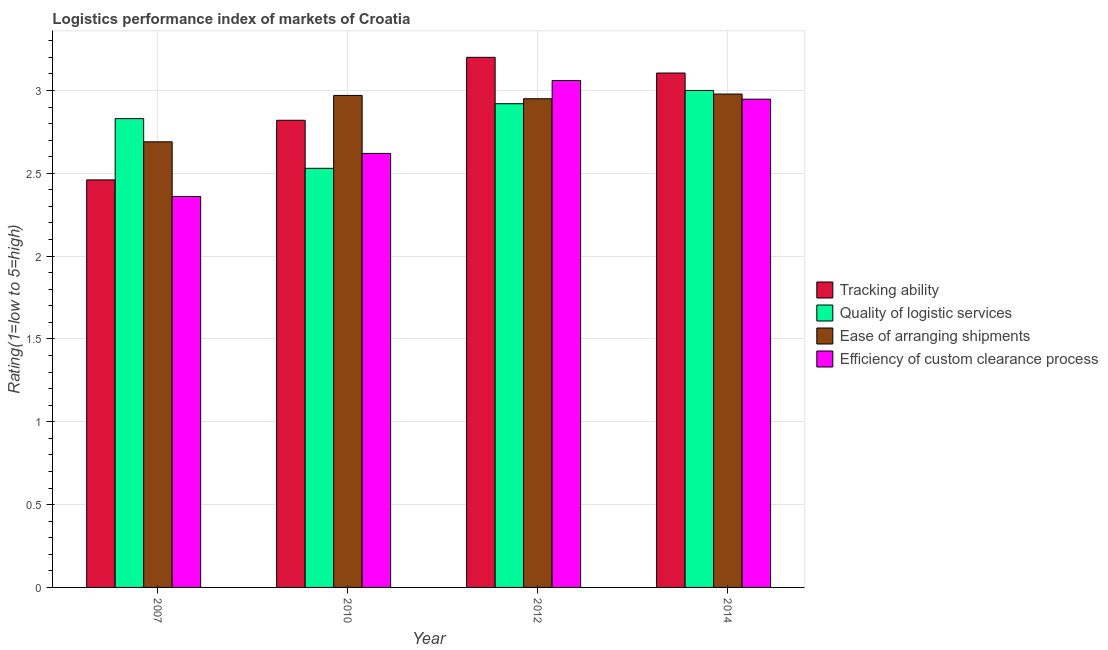How many different coloured bars are there?
Your answer should be very brief. 4. How many groups of bars are there?
Ensure brevity in your answer.  4. Are the number of bars on each tick of the X-axis equal?
Offer a terse response. Yes. What is the lpi rating of efficiency of custom clearance process in 2010?
Offer a terse response. 2.62. Across all years, what is the minimum lpi rating of tracking ability?
Your answer should be compact. 2.46. What is the total lpi rating of quality of logistic services in the graph?
Offer a very short reply. 11.28. What is the difference between the lpi rating of tracking ability in 2007 and that in 2014?
Offer a very short reply. -0.65. What is the difference between the lpi rating of quality of logistic services in 2012 and the lpi rating of tracking ability in 2010?
Your response must be concise. 0.39. What is the average lpi rating of efficiency of custom clearance process per year?
Your answer should be compact. 2.75. What is the ratio of the lpi rating of tracking ability in 2007 to that in 2014?
Ensure brevity in your answer.  0.79. Is the lpi rating of ease of arranging shipments in 2012 less than that in 2014?
Provide a succinct answer. Yes. Is the difference between the lpi rating of quality of logistic services in 2010 and 2012 greater than the difference between the lpi rating of tracking ability in 2010 and 2012?
Offer a terse response. No. What is the difference between the highest and the second highest lpi rating of efficiency of custom clearance process?
Provide a short and direct response. 0.11. What is the difference between the highest and the lowest lpi rating of tracking ability?
Offer a very short reply. 0.74. Is the sum of the lpi rating of efficiency of custom clearance process in 2010 and 2014 greater than the maximum lpi rating of ease of arranging shipments across all years?
Your response must be concise. Yes. What does the 1st bar from the left in 2010 represents?
Your answer should be compact. Tracking ability. What does the 3rd bar from the right in 2012 represents?
Keep it short and to the point. Quality of logistic services. Is it the case that in every year, the sum of the lpi rating of tracking ability and lpi rating of quality of logistic services is greater than the lpi rating of ease of arranging shipments?
Your answer should be very brief. Yes. How many bars are there?
Your answer should be compact. 16. How many years are there in the graph?
Keep it short and to the point. 4. What is the difference between two consecutive major ticks on the Y-axis?
Ensure brevity in your answer.  0.5. Does the graph contain grids?
Keep it short and to the point. Yes. Where does the legend appear in the graph?
Your response must be concise. Center right. How many legend labels are there?
Provide a short and direct response. 4. How are the legend labels stacked?
Ensure brevity in your answer.  Vertical. What is the title of the graph?
Provide a succinct answer. Logistics performance index of markets of Croatia. Does "Tertiary schools" appear as one of the legend labels in the graph?
Give a very brief answer. No. What is the label or title of the X-axis?
Give a very brief answer. Year. What is the label or title of the Y-axis?
Provide a succinct answer. Rating(1=low to 5=high). What is the Rating(1=low to 5=high) of Tracking ability in 2007?
Make the answer very short. 2.46. What is the Rating(1=low to 5=high) of Quality of logistic services in 2007?
Ensure brevity in your answer.  2.83. What is the Rating(1=low to 5=high) in Ease of arranging shipments in 2007?
Offer a terse response. 2.69. What is the Rating(1=low to 5=high) of Efficiency of custom clearance process in 2007?
Provide a succinct answer. 2.36. What is the Rating(1=low to 5=high) in Tracking ability in 2010?
Offer a terse response. 2.82. What is the Rating(1=low to 5=high) of Quality of logistic services in 2010?
Provide a succinct answer. 2.53. What is the Rating(1=low to 5=high) in Ease of arranging shipments in 2010?
Make the answer very short. 2.97. What is the Rating(1=low to 5=high) in Efficiency of custom clearance process in 2010?
Provide a short and direct response. 2.62. What is the Rating(1=low to 5=high) of Quality of logistic services in 2012?
Make the answer very short. 2.92. What is the Rating(1=low to 5=high) of Ease of arranging shipments in 2012?
Your answer should be compact. 2.95. What is the Rating(1=low to 5=high) in Efficiency of custom clearance process in 2012?
Ensure brevity in your answer.  3.06. What is the Rating(1=low to 5=high) in Tracking ability in 2014?
Your answer should be compact. 3.11. What is the Rating(1=low to 5=high) of Quality of logistic services in 2014?
Provide a short and direct response. 3. What is the Rating(1=low to 5=high) in Ease of arranging shipments in 2014?
Your response must be concise. 2.98. What is the Rating(1=low to 5=high) in Efficiency of custom clearance process in 2014?
Keep it short and to the point. 2.95. Across all years, what is the maximum Rating(1=low to 5=high) of Quality of logistic services?
Your response must be concise. 3. Across all years, what is the maximum Rating(1=low to 5=high) of Ease of arranging shipments?
Give a very brief answer. 2.98. Across all years, what is the maximum Rating(1=low to 5=high) in Efficiency of custom clearance process?
Your response must be concise. 3.06. Across all years, what is the minimum Rating(1=low to 5=high) of Tracking ability?
Your response must be concise. 2.46. Across all years, what is the minimum Rating(1=low to 5=high) in Quality of logistic services?
Ensure brevity in your answer.  2.53. Across all years, what is the minimum Rating(1=low to 5=high) of Ease of arranging shipments?
Provide a succinct answer. 2.69. Across all years, what is the minimum Rating(1=low to 5=high) of Efficiency of custom clearance process?
Your response must be concise. 2.36. What is the total Rating(1=low to 5=high) of Tracking ability in the graph?
Offer a terse response. 11.59. What is the total Rating(1=low to 5=high) in Quality of logistic services in the graph?
Ensure brevity in your answer.  11.28. What is the total Rating(1=low to 5=high) of Ease of arranging shipments in the graph?
Your response must be concise. 11.59. What is the total Rating(1=low to 5=high) in Efficiency of custom clearance process in the graph?
Keep it short and to the point. 10.99. What is the difference between the Rating(1=low to 5=high) in Tracking ability in 2007 and that in 2010?
Offer a terse response. -0.36. What is the difference between the Rating(1=low to 5=high) of Ease of arranging shipments in 2007 and that in 2010?
Your answer should be compact. -0.28. What is the difference between the Rating(1=low to 5=high) in Efficiency of custom clearance process in 2007 and that in 2010?
Make the answer very short. -0.26. What is the difference between the Rating(1=low to 5=high) of Tracking ability in 2007 and that in 2012?
Your response must be concise. -0.74. What is the difference between the Rating(1=low to 5=high) of Quality of logistic services in 2007 and that in 2012?
Provide a succinct answer. -0.09. What is the difference between the Rating(1=low to 5=high) of Ease of arranging shipments in 2007 and that in 2012?
Offer a very short reply. -0.26. What is the difference between the Rating(1=low to 5=high) of Efficiency of custom clearance process in 2007 and that in 2012?
Offer a very short reply. -0.7. What is the difference between the Rating(1=low to 5=high) of Tracking ability in 2007 and that in 2014?
Keep it short and to the point. -0.65. What is the difference between the Rating(1=low to 5=high) in Quality of logistic services in 2007 and that in 2014?
Give a very brief answer. -0.17. What is the difference between the Rating(1=low to 5=high) in Ease of arranging shipments in 2007 and that in 2014?
Offer a terse response. -0.29. What is the difference between the Rating(1=low to 5=high) in Efficiency of custom clearance process in 2007 and that in 2014?
Give a very brief answer. -0.59. What is the difference between the Rating(1=low to 5=high) in Tracking ability in 2010 and that in 2012?
Your answer should be compact. -0.38. What is the difference between the Rating(1=low to 5=high) in Quality of logistic services in 2010 and that in 2012?
Ensure brevity in your answer.  -0.39. What is the difference between the Rating(1=low to 5=high) of Ease of arranging shipments in 2010 and that in 2012?
Offer a very short reply. 0.02. What is the difference between the Rating(1=low to 5=high) of Efficiency of custom clearance process in 2010 and that in 2012?
Ensure brevity in your answer.  -0.44. What is the difference between the Rating(1=low to 5=high) of Tracking ability in 2010 and that in 2014?
Provide a succinct answer. -0.29. What is the difference between the Rating(1=low to 5=high) in Quality of logistic services in 2010 and that in 2014?
Offer a very short reply. -0.47. What is the difference between the Rating(1=low to 5=high) of Ease of arranging shipments in 2010 and that in 2014?
Ensure brevity in your answer.  -0.01. What is the difference between the Rating(1=low to 5=high) of Efficiency of custom clearance process in 2010 and that in 2014?
Provide a short and direct response. -0.33. What is the difference between the Rating(1=low to 5=high) of Tracking ability in 2012 and that in 2014?
Provide a succinct answer. 0.09. What is the difference between the Rating(1=low to 5=high) of Quality of logistic services in 2012 and that in 2014?
Make the answer very short. -0.08. What is the difference between the Rating(1=low to 5=high) of Ease of arranging shipments in 2012 and that in 2014?
Offer a terse response. -0.03. What is the difference between the Rating(1=low to 5=high) of Efficiency of custom clearance process in 2012 and that in 2014?
Give a very brief answer. 0.11. What is the difference between the Rating(1=low to 5=high) in Tracking ability in 2007 and the Rating(1=low to 5=high) in Quality of logistic services in 2010?
Make the answer very short. -0.07. What is the difference between the Rating(1=low to 5=high) of Tracking ability in 2007 and the Rating(1=low to 5=high) of Ease of arranging shipments in 2010?
Give a very brief answer. -0.51. What is the difference between the Rating(1=low to 5=high) in Tracking ability in 2007 and the Rating(1=low to 5=high) in Efficiency of custom clearance process in 2010?
Keep it short and to the point. -0.16. What is the difference between the Rating(1=low to 5=high) in Quality of logistic services in 2007 and the Rating(1=low to 5=high) in Ease of arranging shipments in 2010?
Give a very brief answer. -0.14. What is the difference between the Rating(1=low to 5=high) in Quality of logistic services in 2007 and the Rating(1=low to 5=high) in Efficiency of custom clearance process in 2010?
Make the answer very short. 0.21. What is the difference between the Rating(1=low to 5=high) in Ease of arranging shipments in 2007 and the Rating(1=low to 5=high) in Efficiency of custom clearance process in 2010?
Ensure brevity in your answer.  0.07. What is the difference between the Rating(1=low to 5=high) of Tracking ability in 2007 and the Rating(1=low to 5=high) of Quality of logistic services in 2012?
Your answer should be compact. -0.46. What is the difference between the Rating(1=low to 5=high) of Tracking ability in 2007 and the Rating(1=low to 5=high) of Ease of arranging shipments in 2012?
Ensure brevity in your answer.  -0.49. What is the difference between the Rating(1=low to 5=high) in Quality of logistic services in 2007 and the Rating(1=low to 5=high) in Ease of arranging shipments in 2012?
Offer a terse response. -0.12. What is the difference between the Rating(1=low to 5=high) in Quality of logistic services in 2007 and the Rating(1=low to 5=high) in Efficiency of custom clearance process in 2012?
Give a very brief answer. -0.23. What is the difference between the Rating(1=low to 5=high) of Ease of arranging shipments in 2007 and the Rating(1=low to 5=high) of Efficiency of custom clearance process in 2012?
Offer a terse response. -0.37. What is the difference between the Rating(1=low to 5=high) of Tracking ability in 2007 and the Rating(1=low to 5=high) of Quality of logistic services in 2014?
Offer a very short reply. -0.54. What is the difference between the Rating(1=low to 5=high) of Tracking ability in 2007 and the Rating(1=low to 5=high) of Ease of arranging shipments in 2014?
Provide a succinct answer. -0.52. What is the difference between the Rating(1=low to 5=high) of Tracking ability in 2007 and the Rating(1=low to 5=high) of Efficiency of custom clearance process in 2014?
Provide a short and direct response. -0.49. What is the difference between the Rating(1=low to 5=high) in Quality of logistic services in 2007 and the Rating(1=low to 5=high) in Ease of arranging shipments in 2014?
Give a very brief answer. -0.15. What is the difference between the Rating(1=low to 5=high) of Quality of logistic services in 2007 and the Rating(1=low to 5=high) of Efficiency of custom clearance process in 2014?
Keep it short and to the point. -0.12. What is the difference between the Rating(1=low to 5=high) of Ease of arranging shipments in 2007 and the Rating(1=low to 5=high) of Efficiency of custom clearance process in 2014?
Provide a succinct answer. -0.26. What is the difference between the Rating(1=low to 5=high) of Tracking ability in 2010 and the Rating(1=low to 5=high) of Ease of arranging shipments in 2012?
Give a very brief answer. -0.13. What is the difference between the Rating(1=low to 5=high) in Tracking ability in 2010 and the Rating(1=low to 5=high) in Efficiency of custom clearance process in 2012?
Your answer should be very brief. -0.24. What is the difference between the Rating(1=low to 5=high) in Quality of logistic services in 2010 and the Rating(1=low to 5=high) in Ease of arranging shipments in 2012?
Your answer should be compact. -0.42. What is the difference between the Rating(1=low to 5=high) of Quality of logistic services in 2010 and the Rating(1=low to 5=high) of Efficiency of custom clearance process in 2012?
Provide a succinct answer. -0.53. What is the difference between the Rating(1=low to 5=high) of Ease of arranging shipments in 2010 and the Rating(1=low to 5=high) of Efficiency of custom clearance process in 2012?
Keep it short and to the point. -0.09. What is the difference between the Rating(1=low to 5=high) of Tracking ability in 2010 and the Rating(1=low to 5=high) of Quality of logistic services in 2014?
Offer a very short reply. -0.18. What is the difference between the Rating(1=low to 5=high) in Tracking ability in 2010 and the Rating(1=low to 5=high) in Ease of arranging shipments in 2014?
Offer a terse response. -0.16. What is the difference between the Rating(1=low to 5=high) in Tracking ability in 2010 and the Rating(1=low to 5=high) in Efficiency of custom clearance process in 2014?
Offer a very short reply. -0.13. What is the difference between the Rating(1=low to 5=high) of Quality of logistic services in 2010 and the Rating(1=low to 5=high) of Ease of arranging shipments in 2014?
Provide a succinct answer. -0.45. What is the difference between the Rating(1=low to 5=high) of Quality of logistic services in 2010 and the Rating(1=low to 5=high) of Efficiency of custom clearance process in 2014?
Ensure brevity in your answer.  -0.42. What is the difference between the Rating(1=low to 5=high) in Ease of arranging shipments in 2010 and the Rating(1=low to 5=high) in Efficiency of custom clearance process in 2014?
Offer a terse response. 0.02. What is the difference between the Rating(1=low to 5=high) in Tracking ability in 2012 and the Rating(1=low to 5=high) in Ease of arranging shipments in 2014?
Keep it short and to the point. 0.22. What is the difference between the Rating(1=low to 5=high) of Tracking ability in 2012 and the Rating(1=low to 5=high) of Efficiency of custom clearance process in 2014?
Provide a succinct answer. 0.25. What is the difference between the Rating(1=low to 5=high) in Quality of logistic services in 2012 and the Rating(1=low to 5=high) in Ease of arranging shipments in 2014?
Your answer should be very brief. -0.06. What is the difference between the Rating(1=low to 5=high) of Quality of logistic services in 2012 and the Rating(1=low to 5=high) of Efficiency of custom clearance process in 2014?
Provide a succinct answer. -0.03. What is the difference between the Rating(1=low to 5=high) in Ease of arranging shipments in 2012 and the Rating(1=low to 5=high) in Efficiency of custom clearance process in 2014?
Your answer should be compact. 0. What is the average Rating(1=low to 5=high) in Tracking ability per year?
Provide a succinct answer. 2.9. What is the average Rating(1=low to 5=high) of Quality of logistic services per year?
Offer a terse response. 2.82. What is the average Rating(1=low to 5=high) in Ease of arranging shipments per year?
Offer a terse response. 2.9. What is the average Rating(1=low to 5=high) of Efficiency of custom clearance process per year?
Your response must be concise. 2.75. In the year 2007, what is the difference between the Rating(1=low to 5=high) in Tracking ability and Rating(1=low to 5=high) in Quality of logistic services?
Make the answer very short. -0.37. In the year 2007, what is the difference between the Rating(1=low to 5=high) in Tracking ability and Rating(1=low to 5=high) in Ease of arranging shipments?
Your answer should be compact. -0.23. In the year 2007, what is the difference between the Rating(1=low to 5=high) of Tracking ability and Rating(1=low to 5=high) of Efficiency of custom clearance process?
Your answer should be compact. 0.1. In the year 2007, what is the difference between the Rating(1=low to 5=high) in Quality of logistic services and Rating(1=low to 5=high) in Ease of arranging shipments?
Provide a short and direct response. 0.14. In the year 2007, what is the difference between the Rating(1=low to 5=high) in Quality of logistic services and Rating(1=low to 5=high) in Efficiency of custom clearance process?
Make the answer very short. 0.47. In the year 2007, what is the difference between the Rating(1=low to 5=high) of Ease of arranging shipments and Rating(1=low to 5=high) of Efficiency of custom clearance process?
Ensure brevity in your answer.  0.33. In the year 2010, what is the difference between the Rating(1=low to 5=high) of Tracking ability and Rating(1=low to 5=high) of Quality of logistic services?
Ensure brevity in your answer.  0.29. In the year 2010, what is the difference between the Rating(1=low to 5=high) in Quality of logistic services and Rating(1=low to 5=high) in Ease of arranging shipments?
Offer a terse response. -0.44. In the year 2010, what is the difference between the Rating(1=low to 5=high) of Quality of logistic services and Rating(1=low to 5=high) of Efficiency of custom clearance process?
Provide a succinct answer. -0.09. In the year 2012, what is the difference between the Rating(1=low to 5=high) in Tracking ability and Rating(1=low to 5=high) in Quality of logistic services?
Your response must be concise. 0.28. In the year 2012, what is the difference between the Rating(1=low to 5=high) in Tracking ability and Rating(1=low to 5=high) in Ease of arranging shipments?
Provide a short and direct response. 0.25. In the year 2012, what is the difference between the Rating(1=low to 5=high) of Tracking ability and Rating(1=low to 5=high) of Efficiency of custom clearance process?
Keep it short and to the point. 0.14. In the year 2012, what is the difference between the Rating(1=low to 5=high) in Quality of logistic services and Rating(1=low to 5=high) in Ease of arranging shipments?
Your response must be concise. -0.03. In the year 2012, what is the difference between the Rating(1=low to 5=high) in Quality of logistic services and Rating(1=low to 5=high) in Efficiency of custom clearance process?
Give a very brief answer. -0.14. In the year 2012, what is the difference between the Rating(1=low to 5=high) in Ease of arranging shipments and Rating(1=low to 5=high) in Efficiency of custom clearance process?
Make the answer very short. -0.11. In the year 2014, what is the difference between the Rating(1=low to 5=high) of Tracking ability and Rating(1=low to 5=high) of Quality of logistic services?
Make the answer very short. 0.11. In the year 2014, what is the difference between the Rating(1=low to 5=high) in Tracking ability and Rating(1=low to 5=high) in Ease of arranging shipments?
Ensure brevity in your answer.  0.13. In the year 2014, what is the difference between the Rating(1=low to 5=high) in Tracking ability and Rating(1=low to 5=high) in Efficiency of custom clearance process?
Ensure brevity in your answer.  0.16. In the year 2014, what is the difference between the Rating(1=low to 5=high) in Quality of logistic services and Rating(1=low to 5=high) in Ease of arranging shipments?
Offer a terse response. 0.02. In the year 2014, what is the difference between the Rating(1=low to 5=high) in Quality of logistic services and Rating(1=low to 5=high) in Efficiency of custom clearance process?
Your answer should be compact. 0.05. In the year 2014, what is the difference between the Rating(1=low to 5=high) of Ease of arranging shipments and Rating(1=low to 5=high) of Efficiency of custom clearance process?
Provide a short and direct response. 0.03. What is the ratio of the Rating(1=low to 5=high) in Tracking ability in 2007 to that in 2010?
Your response must be concise. 0.87. What is the ratio of the Rating(1=low to 5=high) of Quality of logistic services in 2007 to that in 2010?
Offer a terse response. 1.12. What is the ratio of the Rating(1=low to 5=high) of Ease of arranging shipments in 2007 to that in 2010?
Offer a very short reply. 0.91. What is the ratio of the Rating(1=low to 5=high) in Efficiency of custom clearance process in 2007 to that in 2010?
Offer a very short reply. 0.9. What is the ratio of the Rating(1=low to 5=high) in Tracking ability in 2007 to that in 2012?
Your answer should be compact. 0.77. What is the ratio of the Rating(1=low to 5=high) of Quality of logistic services in 2007 to that in 2012?
Make the answer very short. 0.97. What is the ratio of the Rating(1=low to 5=high) of Ease of arranging shipments in 2007 to that in 2012?
Your response must be concise. 0.91. What is the ratio of the Rating(1=low to 5=high) in Efficiency of custom clearance process in 2007 to that in 2012?
Keep it short and to the point. 0.77. What is the ratio of the Rating(1=low to 5=high) of Tracking ability in 2007 to that in 2014?
Make the answer very short. 0.79. What is the ratio of the Rating(1=low to 5=high) of Quality of logistic services in 2007 to that in 2014?
Your answer should be very brief. 0.94. What is the ratio of the Rating(1=low to 5=high) of Ease of arranging shipments in 2007 to that in 2014?
Offer a terse response. 0.9. What is the ratio of the Rating(1=low to 5=high) of Efficiency of custom clearance process in 2007 to that in 2014?
Provide a succinct answer. 0.8. What is the ratio of the Rating(1=low to 5=high) in Tracking ability in 2010 to that in 2012?
Ensure brevity in your answer.  0.88. What is the ratio of the Rating(1=low to 5=high) of Quality of logistic services in 2010 to that in 2012?
Provide a short and direct response. 0.87. What is the ratio of the Rating(1=low to 5=high) in Ease of arranging shipments in 2010 to that in 2012?
Make the answer very short. 1.01. What is the ratio of the Rating(1=low to 5=high) in Efficiency of custom clearance process in 2010 to that in 2012?
Your response must be concise. 0.86. What is the ratio of the Rating(1=low to 5=high) in Tracking ability in 2010 to that in 2014?
Make the answer very short. 0.91. What is the ratio of the Rating(1=low to 5=high) of Quality of logistic services in 2010 to that in 2014?
Offer a very short reply. 0.84. What is the ratio of the Rating(1=low to 5=high) in Efficiency of custom clearance process in 2010 to that in 2014?
Make the answer very short. 0.89. What is the ratio of the Rating(1=low to 5=high) of Tracking ability in 2012 to that in 2014?
Your answer should be very brief. 1.03. What is the ratio of the Rating(1=low to 5=high) of Quality of logistic services in 2012 to that in 2014?
Offer a very short reply. 0.97. What is the ratio of the Rating(1=low to 5=high) of Efficiency of custom clearance process in 2012 to that in 2014?
Offer a terse response. 1.04. What is the difference between the highest and the second highest Rating(1=low to 5=high) in Tracking ability?
Your answer should be very brief. 0.09. What is the difference between the highest and the second highest Rating(1=low to 5=high) in Quality of logistic services?
Provide a short and direct response. 0.08. What is the difference between the highest and the second highest Rating(1=low to 5=high) in Ease of arranging shipments?
Your answer should be compact. 0.01. What is the difference between the highest and the second highest Rating(1=low to 5=high) of Efficiency of custom clearance process?
Ensure brevity in your answer.  0.11. What is the difference between the highest and the lowest Rating(1=low to 5=high) in Tracking ability?
Keep it short and to the point. 0.74. What is the difference between the highest and the lowest Rating(1=low to 5=high) of Quality of logistic services?
Provide a succinct answer. 0.47. What is the difference between the highest and the lowest Rating(1=low to 5=high) in Ease of arranging shipments?
Your response must be concise. 0.29. 